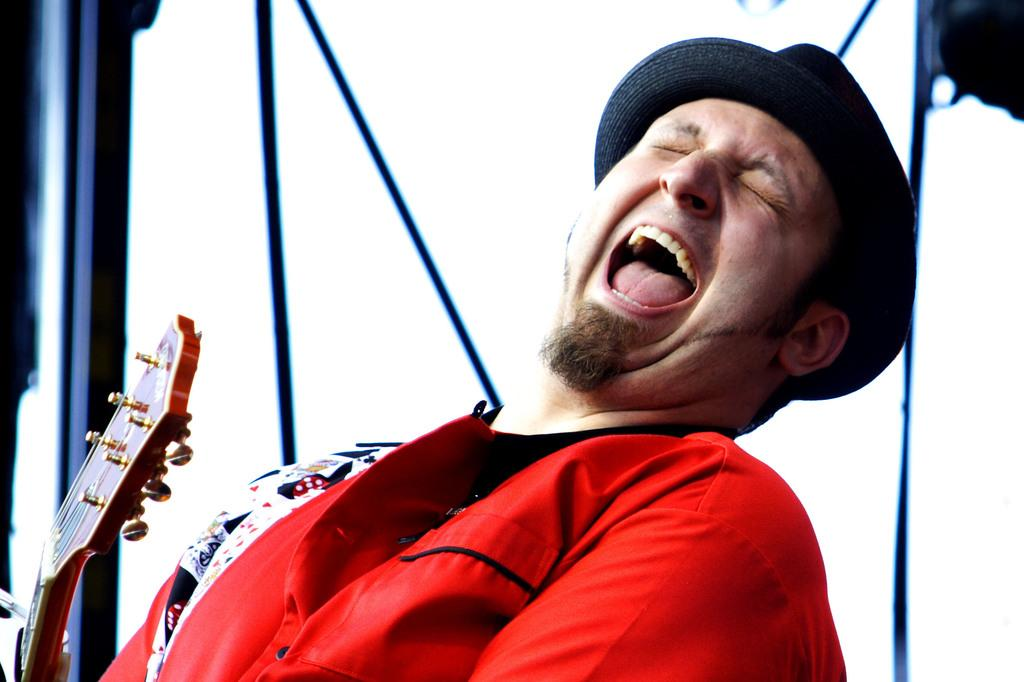Who is present in the image? There is a man in the image. What is the man doing with his eyes and mouth? The man has his eyes closed and his mouth open. What object can be seen on the left side of the image? There is a guitar on the left side of the image. What type of protest is the man's aunt participating in, as seen in the image? There is no protest or aunt present in the image; it only features a man with his eyes closed and mouth open, and a guitar on the left side. 